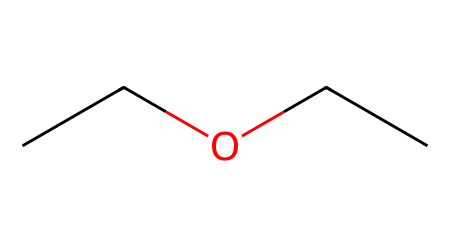What is the name of this compound? The SMILES representation "CCOCC" corresponds to diethyl ether, which is commonly used as a solvent and is characterized by its ether functional group.
Answer: diethyl ether How many carbon atoms are in the structure? By analyzing the SMILES "CCOCC", we can count the 'C's, which indicates there are five carbon atoms present in total.
Answer: five What functional group is present in this compound? The structure contains an ether functional group, characterized by the presence of an oxygen atom bonded to two carbon chains (in this case, ethyl groups).
Answer: ether How many oxygen atoms are present in the molecule? In the provided SMILES "CCOCC", we see one 'O', indicating that there is a single oxygen atom in the structure.
Answer: one Is this compound polar or nonpolar? The presence of the ether oxygen can impart some polarity to the compound, but because diethyl ether also has large hydrophobic carbon chains, it is considered mostly nonpolar.
Answer: nonpolar What type of reactions can diethyl ether undergo? As an ether, diethyl ether can participate in cleavage reactions under strong acidic conditions but is generally stable under normal conditions, mainly serving as a solvent.
Answer: cleavage 